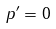Convert formula to latex. <formula><loc_0><loc_0><loc_500><loc_500>p ^ { \prime } = 0</formula> 